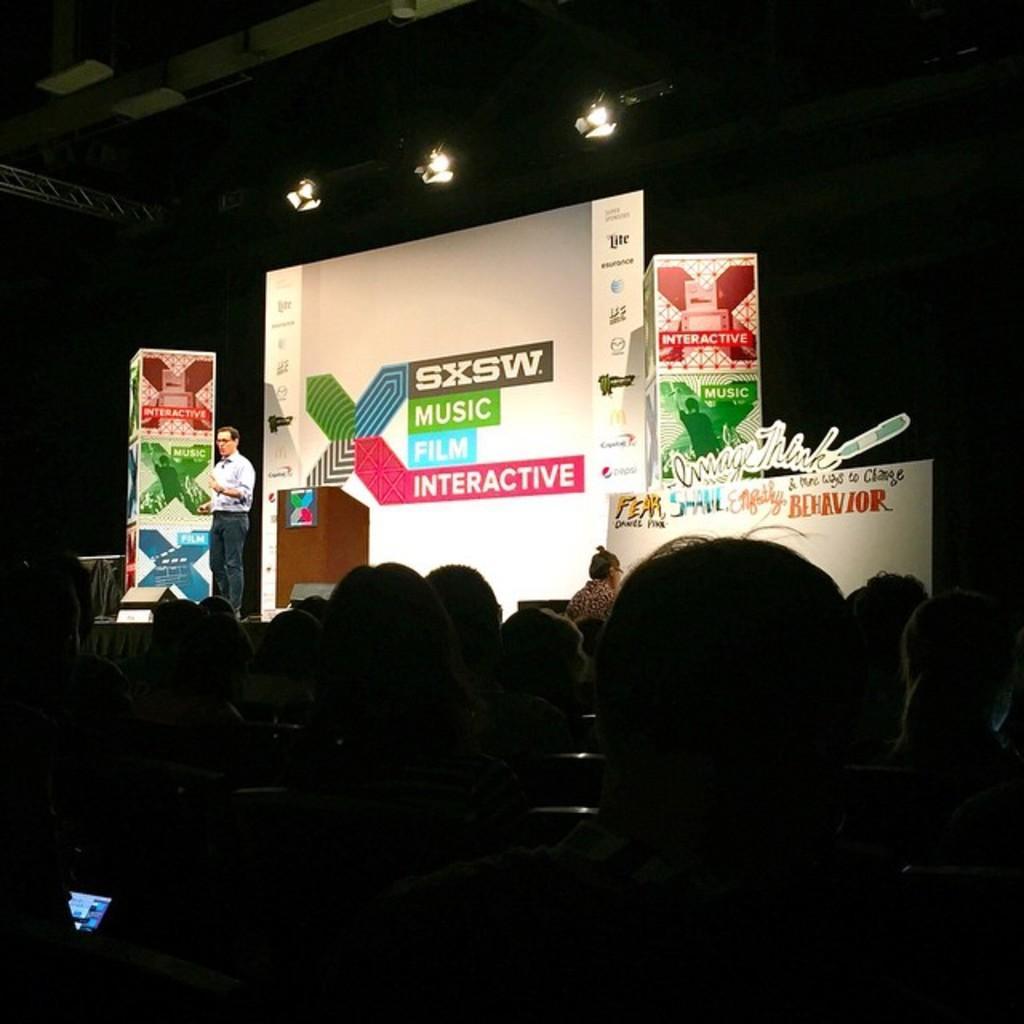Describe this image in one or two sentences. In the picture I can see a person standing and speaking and there are few audience in front of him and there are few banners which has something written on it in the background and there are few lights above it. 